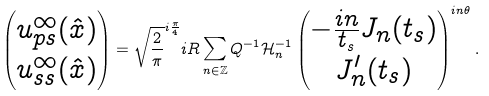<formula> <loc_0><loc_0><loc_500><loc_500>\begin{pmatrix} u ^ { \infty } _ { p s } ( \hat { x } ) \\ u ^ { \infty } _ { s s } ( \hat { x } ) \end{pmatrix} = \sqrt { \frac { 2 } { \pi } } ^ { i \frac { \pi } { 4 } } i R \sum _ { n \in \mathbb { Z } } Q ^ { - 1 } \mathcal { H } _ { n } ^ { - 1 } \begin{pmatrix} - \frac { i n } { t _ { s } } J _ { n } ( t _ { s } ) \\ J ^ { \prime } _ { n } ( t _ { s } ) \end{pmatrix} ^ { i n \theta } .</formula> 